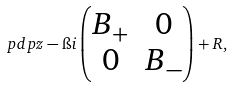<formula> <loc_0><loc_0><loc_500><loc_500>\ p d p { z } - \i i \left ( \begin{matrix} B _ { + } & 0 \\ 0 & B _ { - } \end{matrix} \right ) + R ,</formula> 